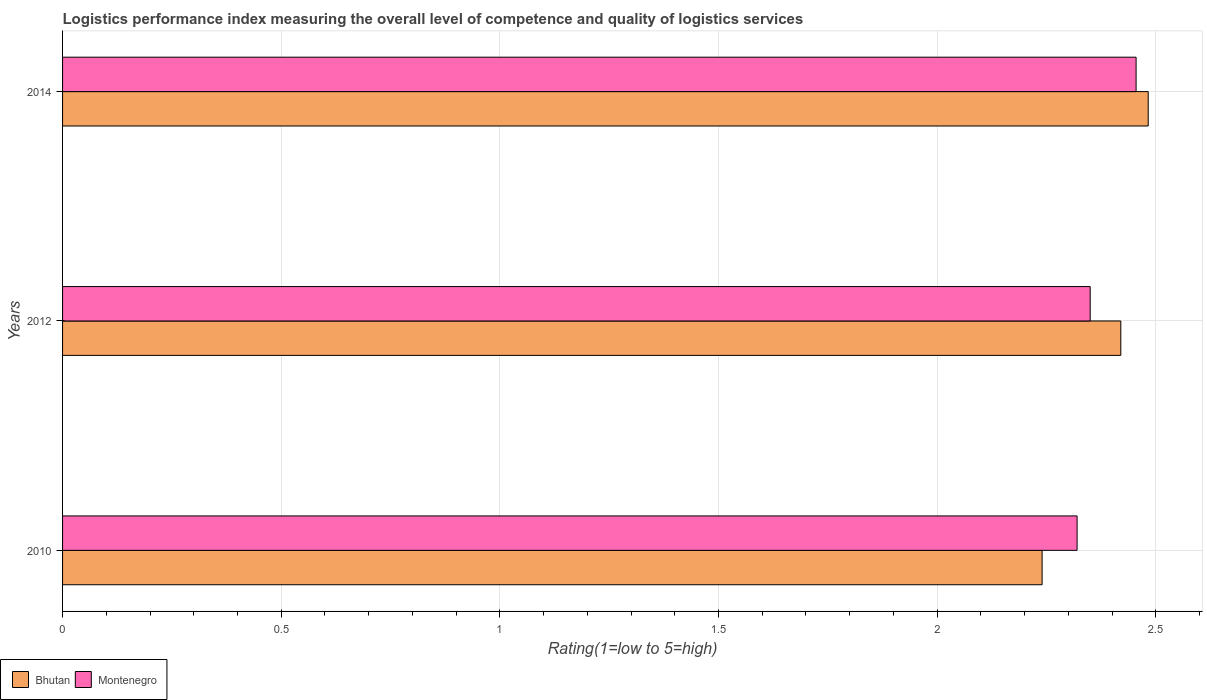Are the number of bars per tick equal to the number of legend labels?
Your response must be concise. Yes. Are the number of bars on each tick of the Y-axis equal?
Keep it short and to the point. Yes. How many bars are there on the 2nd tick from the top?
Offer a very short reply. 2. What is the label of the 3rd group of bars from the top?
Make the answer very short. 2010. In how many cases, is the number of bars for a given year not equal to the number of legend labels?
Keep it short and to the point. 0. What is the Logistic performance index in Bhutan in 2014?
Your answer should be very brief. 2.48. Across all years, what is the maximum Logistic performance index in Montenegro?
Offer a terse response. 2.45. Across all years, what is the minimum Logistic performance index in Montenegro?
Your response must be concise. 2.32. What is the total Logistic performance index in Bhutan in the graph?
Provide a short and direct response. 7.14. What is the difference between the Logistic performance index in Bhutan in 2010 and that in 2014?
Keep it short and to the point. -0.24. What is the difference between the Logistic performance index in Bhutan in 2010 and the Logistic performance index in Montenegro in 2012?
Provide a short and direct response. -0.11. What is the average Logistic performance index in Bhutan per year?
Make the answer very short. 2.38. In the year 2010, what is the difference between the Logistic performance index in Montenegro and Logistic performance index in Bhutan?
Ensure brevity in your answer.  0.08. What is the ratio of the Logistic performance index in Bhutan in 2010 to that in 2012?
Provide a short and direct response. 0.93. What is the difference between the highest and the second highest Logistic performance index in Bhutan?
Your answer should be compact. 0.06. What is the difference between the highest and the lowest Logistic performance index in Montenegro?
Your answer should be very brief. 0.13. Is the sum of the Logistic performance index in Bhutan in 2012 and 2014 greater than the maximum Logistic performance index in Montenegro across all years?
Your response must be concise. Yes. What does the 1st bar from the top in 2012 represents?
Your response must be concise. Montenegro. What does the 2nd bar from the bottom in 2010 represents?
Offer a terse response. Montenegro. Are all the bars in the graph horizontal?
Offer a terse response. Yes. How many years are there in the graph?
Your answer should be compact. 3. Does the graph contain any zero values?
Provide a short and direct response. No. What is the title of the graph?
Provide a short and direct response. Logistics performance index measuring the overall level of competence and quality of logistics services. What is the label or title of the X-axis?
Ensure brevity in your answer.  Rating(1=low to 5=high). What is the label or title of the Y-axis?
Your answer should be very brief. Years. What is the Rating(1=low to 5=high) of Bhutan in 2010?
Your response must be concise. 2.24. What is the Rating(1=low to 5=high) of Montenegro in 2010?
Your response must be concise. 2.32. What is the Rating(1=low to 5=high) of Bhutan in 2012?
Your response must be concise. 2.42. What is the Rating(1=low to 5=high) of Montenegro in 2012?
Make the answer very short. 2.35. What is the Rating(1=low to 5=high) of Bhutan in 2014?
Provide a succinct answer. 2.48. What is the Rating(1=low to 5=high) of Montenegro in 2014?
Provide a short and direct response. 2.45. Across all years, what is the maximum Rating(1=low to 5=high) of Bhutan?
Offer a very short reply. 2.48. Across all years, what is the maximum Rating(1=low to 5=high) in Montenegro?
Offer a very short reply. 2.45. Across all years, what is the minimum Rating(1=low to 5=high) of Bhutan?
Make the answer very short. 2.24. Across all years, what is the minimum Rating(1=low to 5=high) in Montenegro?
Provide a succinct answer. 2.32. What is the total Rating(1=low to 5=high) in Bhutan in the graph?
Provide a short and direct response. 7.14. What is the total Rating(1=low to 5=high) in Montenegro in the graph?
Offer a very short reply. 7.12. What is the difference between the Rating(1=low to 5=high) in Bhutan in 2010 and that in 2012?
Give a very brief answer. -0.18. What is the difference between the Rating(1=low to 5=high) in Montenegro in 2010 and that in 2012?
Offer a very short reply. -0.03. What is the difference between the Rating(1=low to 5=high) of Bhutan in 2010 and that in 2014?
Make the answer very short. -0.24. What is the difference between the Rating(1=low to 5=high) in Montenegro in 2010 and that in 2014?
Offer a very short reply. -0.13. What is the difference between the Rating(1=low to 5=high) in Bhutan in 2012 and that in 2014?
Provide a succinct answer. -0.06. What is the difference between the Rating(1=low to 5=high) of Montenegro in 2012 and that in 2014?
Provide a short and direct response. -0.1. What is the difference between the Rating(1=low to 5=high) in Bhutan in 2010 and the Rating(1=low to 5=high) in Montenegro in 2012?
Your answer should be very brief. -0.11. What is the difference between the Rating(1=low to 5=high) of Bhutan in 2010 and the Rating(1=low to 5=high) of Montenegro in 2014?
Your answer should be very brief. -0.21. What is the difference between the Rating(1=low to 5=high) of Bhutan in 2012 and the Rating(1=low to 5=high) of Montenegro in 2014?
Your response must be concise. -0.03. What is the average Rating(1=low to 5=high) of Bhutan per year?
Make the answer very short. 2.38. What is the average Rating(1=low to 5=high) of Montenegro per year?
Provide a succinct answer. 2.38. In the year 2010, what is the difference between the Rating(1=low to 5=high) of Bhutan and Rating(1=low to 5=high) of Montenegro?
Keep it short and to the point. -0.08. In the year 2012, what is the difference between the Rating(1=low to 5=high) of Bhutan and Rating(1=low to 5=high) of Montenegro?
Offer a terse response. 0.07. In the year 2014, what is the difference between the Rating(1=low to 5=high) in Bhutan and Rating(1=low to 5=high) in Montenegro?
Your answer should be very brief. 0.03. What is the ratio of the Rating(1=low to 5=high) of Bhutan in 2010 to that in 2012?
Keep it short and to the point. 0.93. What is the ratio of the Rating(1=low to 5=high) in Montenegro in 2010 to that in 2012?
Offer a very short reply. 0.99. What is the ratio of the Rating(1=low to 5=high) of Bhutan in 2010 to that in 2014?
Your response must be concise. 0.9. What is the ratio of the Rating(1=low to 5=high) of Montenegro in 2010 to that in 2014?
Your answer should be very brief. 0.94. What is the ratio of the Rating(1=low to 5=high) in Bhutan in 2012 to that in 2014?
Make the answer very short. 0.97. What is the ratio of the Rating(1=low to 5=high) in Montenegro in 2012 to that in 2014?
Offer a terse response. 0.96. What is the difference between the highest and the second highest Rating(1=low to 5=high) in Bhutan?
Your response must be concise. 0.06. What is the difference between the highest and the second highest Rating(1=low to 5=high) in Montenegro?
Keep it short and to the point. 0.1. What is the difference between the highest and the lowest Rating(1=low to 5=high) of Bhutan?
Your answer should be very brief. 0.24. What is the difference between the highest and the lowest Rating(1=low to 5=high) in Montenegro?
Offer a very short reply. 0.13. 